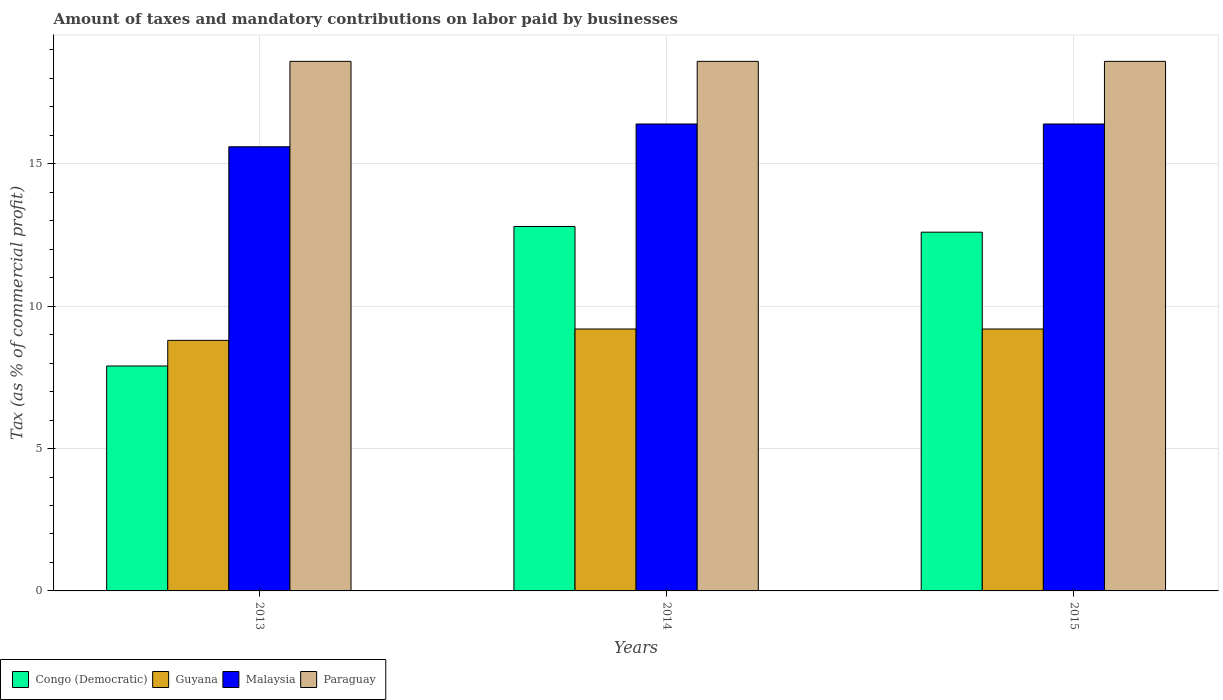How many different coloured bars are there?
Make the answer very short. 4. Are the number of bars per tick equal to the number of legend labels?
Your response must be concise. Yes. How many bars are there on the 2nd tick from the left?
Your response must be concise. 4. What is the label of the 3rd group of bars from the left?
Give a very brief answer. 2015. In how many cases, is the number of bars for a given year not equal to the number of legend labels?
Keep it short and to the point. 0. Across all years, what is the maximum percentage of taxes paid by businesses in Guyana?
Your answer should be compact. 9.2. Across all years, what is the minimum percentage of taxes paid by businesses in Guyana?
Provide a short and direct response. 8.8. In which year was the percentage of taxes paid by businesses in Guyana maximum?
Offer a very short reply. 2014. In which year was the percentage of taxes paid by businesses in Guyana minimum?
Offer a terse response. 2013. What is the total percentage of taxes paid by businesses in Paraguay in the graph?
Your answer should be compact. 55.8. What is the difference between the percentage of taxes paid by businesses in Paraguay in 2014 and that in 2015?
Make the answer very short. 0. What is the difference between the percentage of taxes paid by businesses in Congo (Democratic) in 2015 and the percentage of taxes paid by businesses in Guyana in 2013?
Provide a short and direct response. 3.8. What is the average percentage of taxes paid by businesses in Malaysia per year?
Ensure brevity in your answer.  16.13. In the year 2013, what is the difference between the percentage of taxes paid by businesses in Paraguay and percentage of taxes paid by businesses in Congo (Democratic)?
Ensure brevity in your answer.  10.7. What is the ratio of the percentage of taxes paid by businesses in Malaysia in 2014 to that in 2015?
Offer a terse response. 1. Is the percentage of taxes paid by businesses in Paraguay in 2014 less than that in 2015?
Provide a short and direct response. No. What is the difference between the highest and the second highest percentage of taxes paid by businesses in Paraguay?
Provide a short and direct response. 0. What is the difference between the highest and the lowest percentage of taxes paid by businesses in Guyana?
Give a very brief answer. 0.4. In how many years, is the percentage of taxes paid by businesses in Guyana greater than the average percentage of taxes paid by businesses in Guyana taken over all years?
Keep it short and to the point. 2. What does the 3rd bar from the left in 2013 represents?
Make the answer very short. Malaysia. What does the 3rd bar from the right in 2014 represents?
Offer a very short reply. Guyana. How many bars are there?
Keep it short and to the point. 12. Are all the bars in the graph horizontal?
Ensure brevity in your answer.  No. Where does the legend appear in the graph?
Offer a terse response. Bottom left. How are the legend labels stacked?
Your answer should be compact. Horizontal. What is the title of the graph?
Your answer should be compact. Amount of taxes and mandatory contributions on labor paid by businesses. Does "Kuwait" appear as one of the legend labels in the graph?
Ensure brevity in your answer.  No. What is the label or title of the X-axis?
Ensure brevity in your answer.  Years. What is the label or title of the Y-axis?
Your response must be concise. Tax (as % of commercial profit). What is the Tax (as % of commercial profit) of Congo (Democratic) in 2013?
Offer a very short reply. 7.9. What is the Tax (as % of commercial profit) in Paraguay in 2013?
Your answer should be very brief. 18.6. What is the Tax (as % of commercial profit) of Guyana in 2014?
Make the answer very short. 9.2. What is the Tax (as % of commercial profit) of Paraguay in 2014?
Offer a very short reply. 18.6. What is the Tax (as % of commercial profit) in Malaysia in 2015?
Provide a short and direct response. 16.4. Across all years, what is the maximum Tax (as % of commercial profit) of Congo (Democratic)?
Provide a succinct answer. 12.8. Across all years, what is the minimum Tax (as % of commercial profit) of Guyana?
Provide a succinct answer. 8.8. Across all years, what is the minimum Tax (as % of commercial profit) of Malaysia?
Provide a short and direct response. 15.6. What is the total Tax (as % of commercial profit) of Congo (Democratic) in the graph?
Offer a terse response. 33.3. What is the total Tax (as % of commercial profit) in Guyana in the graph?
Provide a succinct answer. 27.2. What is the total Tax (as % of commercial profit) of Malaysia in the graph?
Your answer should be compact. 48.4. What is the total Tax (as % of commercial profit) of Paraguay in the graph?
Ensure brevity in your answer.  55.8. What is the difference between the Tax (as % of commercial profit) in Congo (Democratic) in 2013 and that in 2014?
Keep it short and to the point. -4.9. What is the difference between the Tax (as % of commercial profit) of Paraguay in 2013 and that in 2014?
Give a very brief answer. 0. What is the difference between the Tax (as % of commercial profit) of Congo (Democratic) in 2013 and that in 2015?
Ensure brevity in your answer.  -4.7. What is the difference between the Tax (as % of commercial profit) of Guyana in 2013 and that in 2015?
Provide a short and direct response. -0.4. What is the difference between the Tax (as % of commercial profit) in Malaysia in 2013 and that in 2015?
Your answer should be very brief. -0.8. What is the difference between the Tax (as % of commercial profit) of Paraguay in 2013 and that in 2015?
Ensure brevity in your answer.  0. What is the difference between the Tax (as % of commercial profit) in Malaysia in 2014 and that in 2015?
Keep it short and to the point. 0. What is the difference between the Tax (as % of commercial profit) in Paraguay in 2014 and that in 2015?
Keep it short and to the point. 0. What is the difference between the Tax (as % of commercial profit) of Congo (Democratic) in 2013 and the Tax (as % of commercial profit) of Malaysia in 2014?
Your response must be concise. -8.5. What is the difference between the Tax (as % of commercial profit) in Congo (Democratic) in 2013 and the Tax (as % of commercial profit) in Paraguay in 2014?
Provide a short and direct response. -10.7. What is the difference between the Tax (as % of commercial profit) of Guyana in 2013 and the Tax (as % of commercial profit) of Malaysia in 2014?
Offer a terse response. -7.6. What is the difference between the Tax (as % of commercial profit) in Guyana in 2013 and the Tax (as % of commercial profit) in Paraguay in 2014?
Keep it short and to the point. -9.8. What is the difference between the Tax (as % of commercial profit) in Malaysia in 2013 and the Tax (as % of commercial profit) in Paraguay in 2014?
Offer a very short reply. -3. What is the difference between the Tax (as % of commercial profit) of Congo (Democratic) in 2013 and the Tax (as % of commercial profit) of Malaysia in 2015?
Ensure brevity in your answer.  -8.5. What is the difference between the Tax (as % of commercial profit) in Guyana in 2013 and the Tax (as % of commercial profit) in Malaysia in 2015?
Offer a very short reply. -7.6. What is the difference between the Tax (as % of commercial profit) in Guyana in 2013 and the Tax (as % of commercial profit) in Paraguay in 2015?
Your answer should be compact. -9.8. What is the difference between the Tax (as % of commercial profit) of Malaysia in 2013 and the Tax (as % of commercial profit) of Paraguay in 2015?
Ensure brevity in your answer.  -3. What is the difference between the Tax (as % of commercial profit) in Congo (Democratic) in 2014 and the Tax (as % of commercial profit) in Guyana in 2015?
Give a very brief answer. 3.6. What is the difference between the Tax (as % of commercial profit) of Congo (Democratic) in 2014 and the Tax (as % of commercial profit) of Malaysia in 2015?
Keep it short and to the point. -3.6. What is the difference between the Tax (as % of commercial profit) of Congo (Democratic) in 2014 and the Tax (as % of commercial profit) of Paraguay in 2015?
Provide a succinct answer. -5.8. What is the difference between the Tax (as % of commercial profit) of Guyana in 2014 and the Tax (as % of commercial profit) of Paraguay in 2015?
Provide a short and direct response. -9.4. What is the average Tax (as % of commercial profit) of Guyana per year?
Your answer should be very brief. 9.07. What is the average Tax (as % of commercial profit) in Malaysia per year?
Your answer should be compact. 16.13. In the year 2013, what is the difference between the Tax (as % of commercial profit) in Guyana and Tax (as % of commercial profit) in Paraguay?
Make the answer very short. -9.8. In the year 2014, what is the difference between the Tax (as % of commercial profit) in Congo (Democratic) and Tax (as % of commercial profit) in Paraguay?
Ensure brevity in your answer.  -5.8. In the year 2014, what is the difference between the Tax (as % of commercial profit) in Guyana and Tax (as % of commercial profit) in Paraguay?
Offer a very short reply. -9.4. In the year 2015, what is the difference between the Tax (as % of commercial profit) in Congo (Democratic) and Tax (as % of commercial profit) in Malaysia?
Keep it short and to the point. -3.8. In the year 2015, what is the difference between the Tax (as % of commercial profit) of Congo (Democratic) and Tax (as % of commercial profit) of Paraguay?
Your answer should be very brief. -6. In the year 2015, what is the difference between the Tax (as % of commercial profit) of Guyana and Tax (as % of commercial profit) of Malaysia?
Keep it short and to the point. -7.2. In the year 2015, what is the difference between the Tax (as % of commercial profit) of Malaysia and Tax (as % of commercial profit) of Paraguay?
Offer a very short reply. -2.2. What is the ratio of the Tax (as % of commercial profit) of Congo (Democratic) in 2013 to that in 2014?
Keep it short and to the point. 0.62. What is the ratio of the Tax (as % of commercial profit) in Guyana in 2013 to that in 2014?
Offer a very short reply. 0.96. What is the ratio of the Tax (as % of commercial profit) in Malaysia in 2013 to that in 2014?
Offer a terse response. 0.95. What is the ratio of the Tax (as % of commercial profit) in Congo (Democratic) in 2013 to that in 2015?
Offer a terse response. 0.63. What is the ratio of the Tax (as % of commercial profit) in Guyana in 2013 to that in 2015?
Offer a very short reply. 0.96. What is the ratio of the Tax (as % of commercial profit) in Malaysia in 2013 to that in 2015?
Your response must be concise. 0.95. What is the ratio of the Tax (as % of commercial profit) of Congo (Democratic) in 2014 to that in 2015?
Offer a terse response. 1.02. What is the ratio of the Tax (as % of commercial profit) of Paraguay in 2014 to that in 2015?
Offer a very short reply. 1. What is the difference between the highest and the lowest Tax (as % of commercial profit) in Malaysia?
Your response must be concise. 0.8. What is the difference between the highest and the lowest Tax (as % of commercial profit) in Paraguay?
Give a very brief answer. 0. 